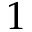Convert formula to latex. <formula><loc_0><loc_0><loc_500><loc_500>1</formula> 